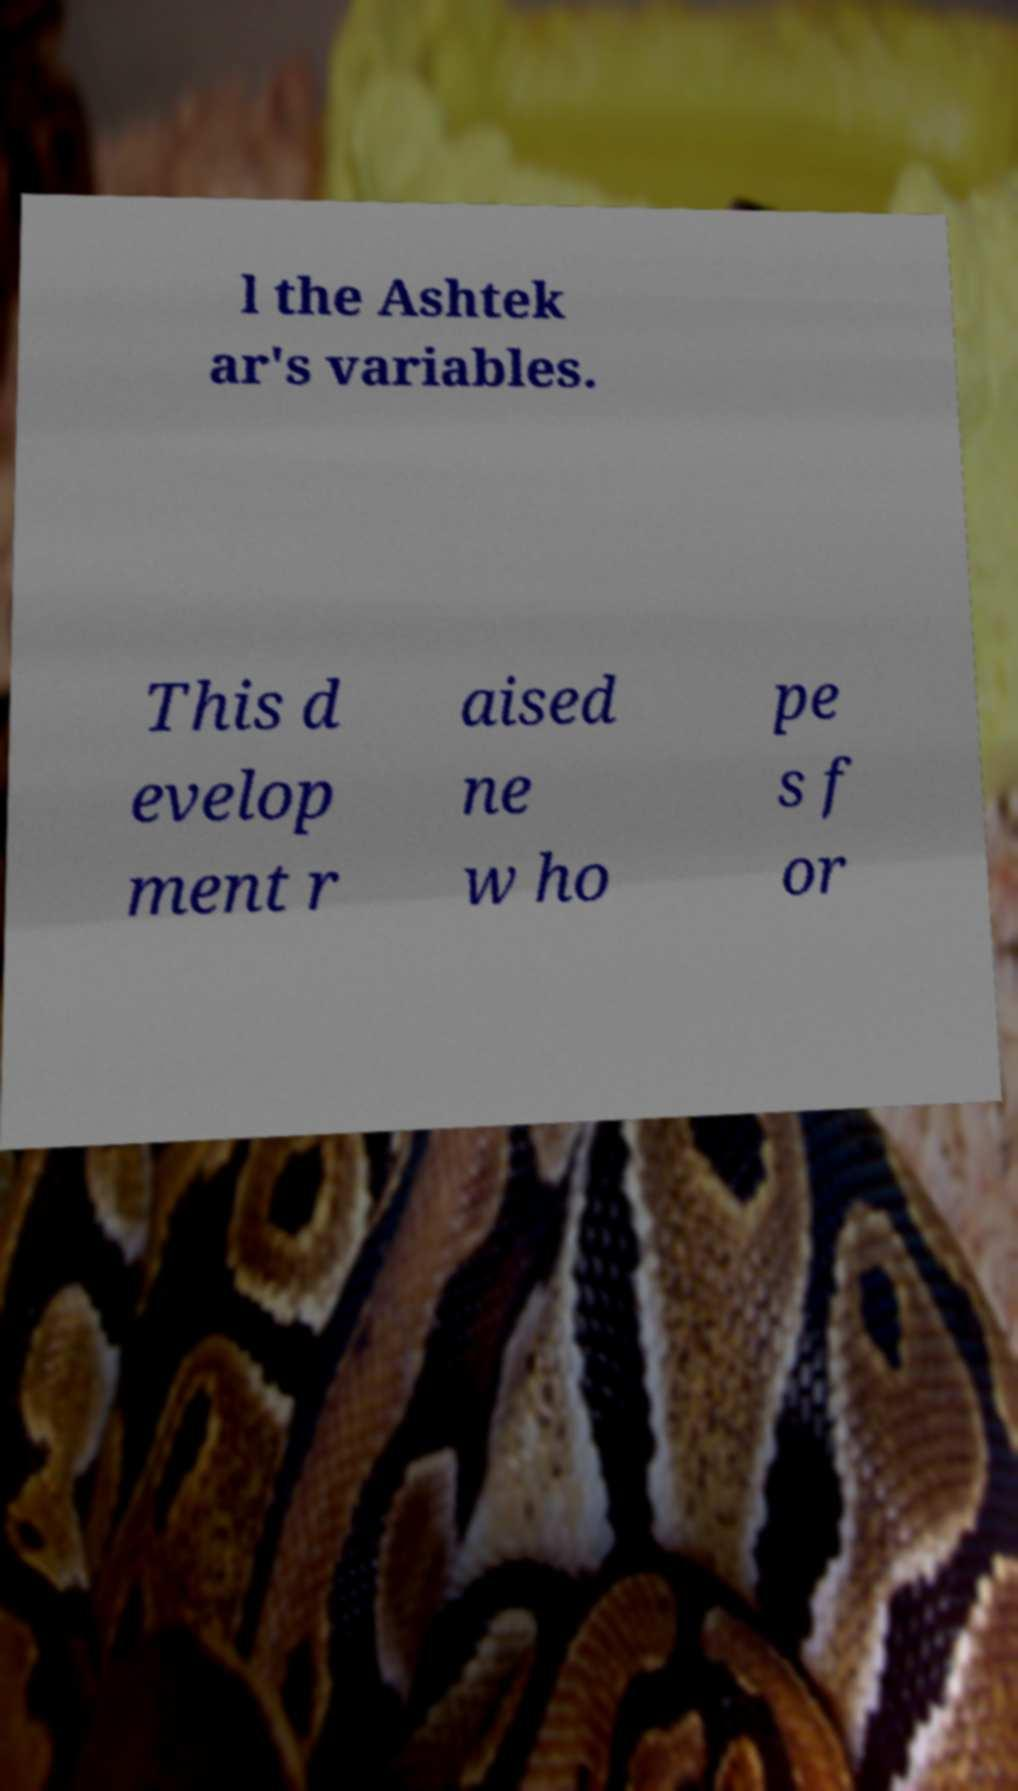For documentation purposes, I need the text within this image transcribed. Could you provide that? l the Ashtek ar's variables. This d evelop ment r aised ne w ho pe s f or 